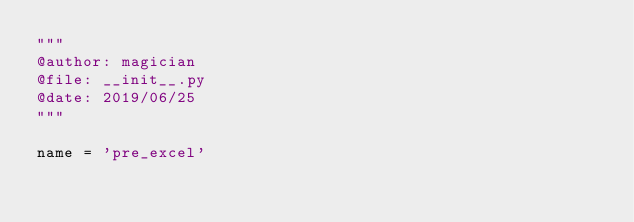<code> <loc_0><loc_0><loc_500><loc_500><_Python_>"""
@author: magician
@file: __init__.py
@date: 2019/06/25
"""

name = 'pre_excel'
</code> 